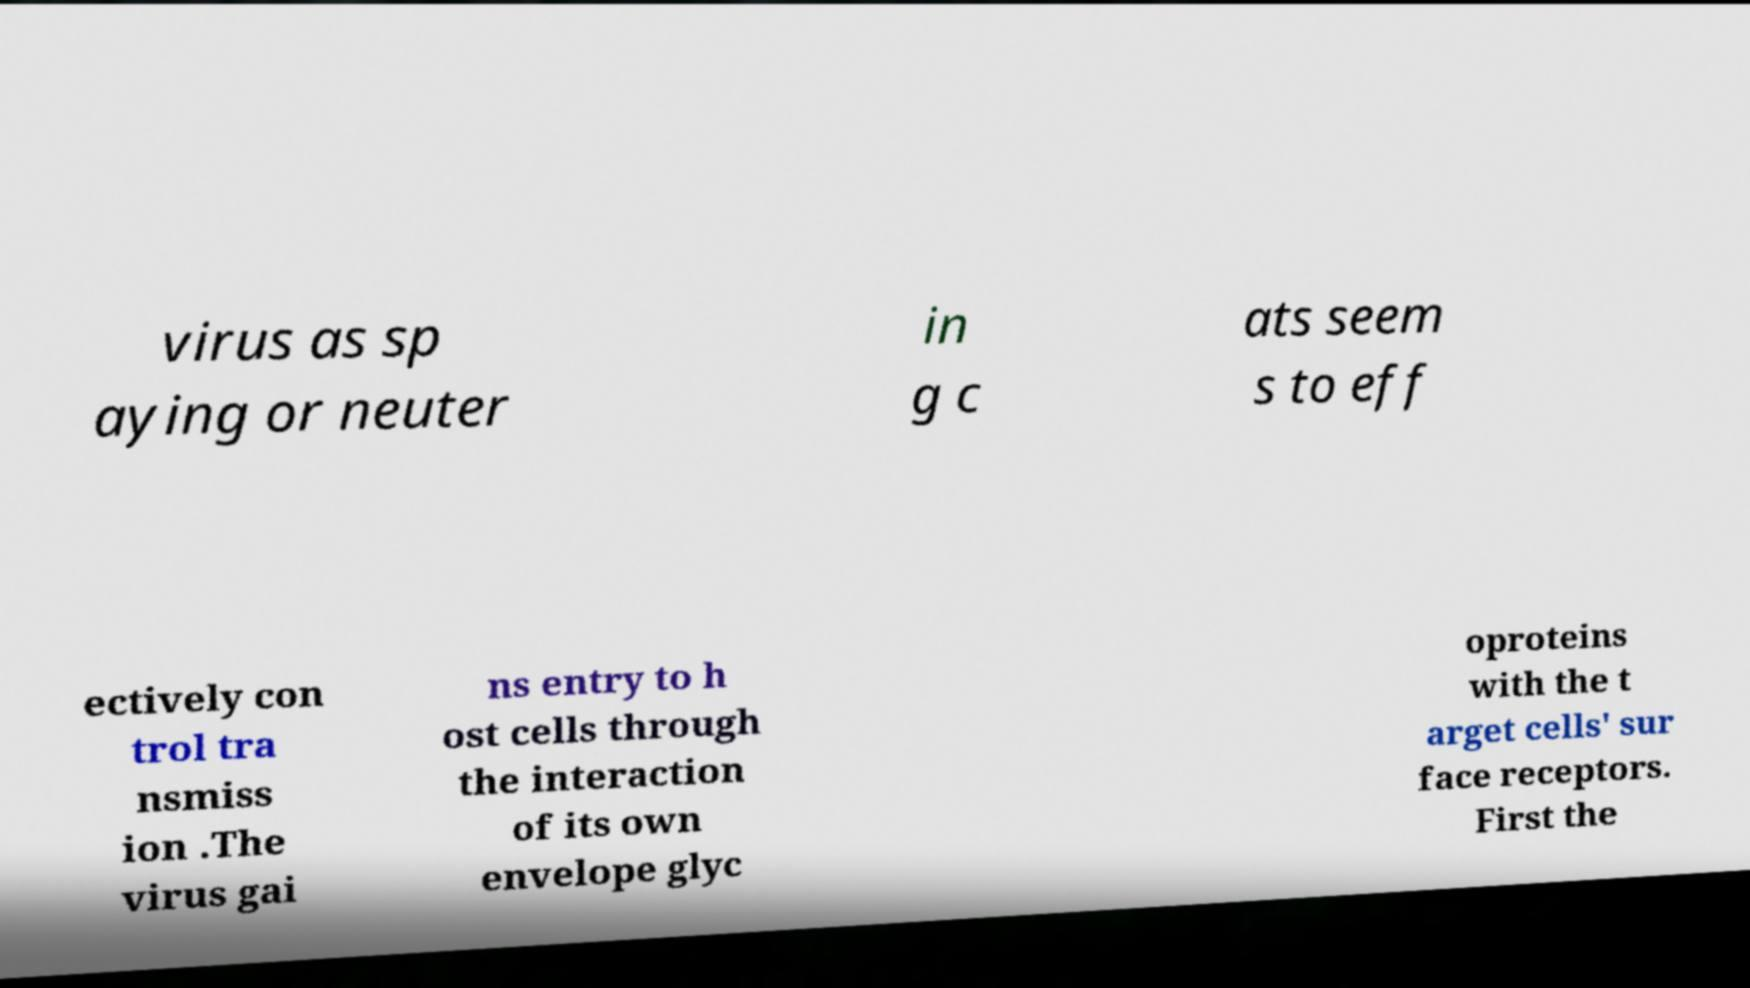Please identify and transcribe the text found in this image. virus as sp aying or neuter in g c ats seem s to eff ectively con trol tra nsmiss ion .The virus gai ns entry to h ost cells through the interaction of its own envelope glyc oproteins with the t arget cells' sur face receptors. First the 